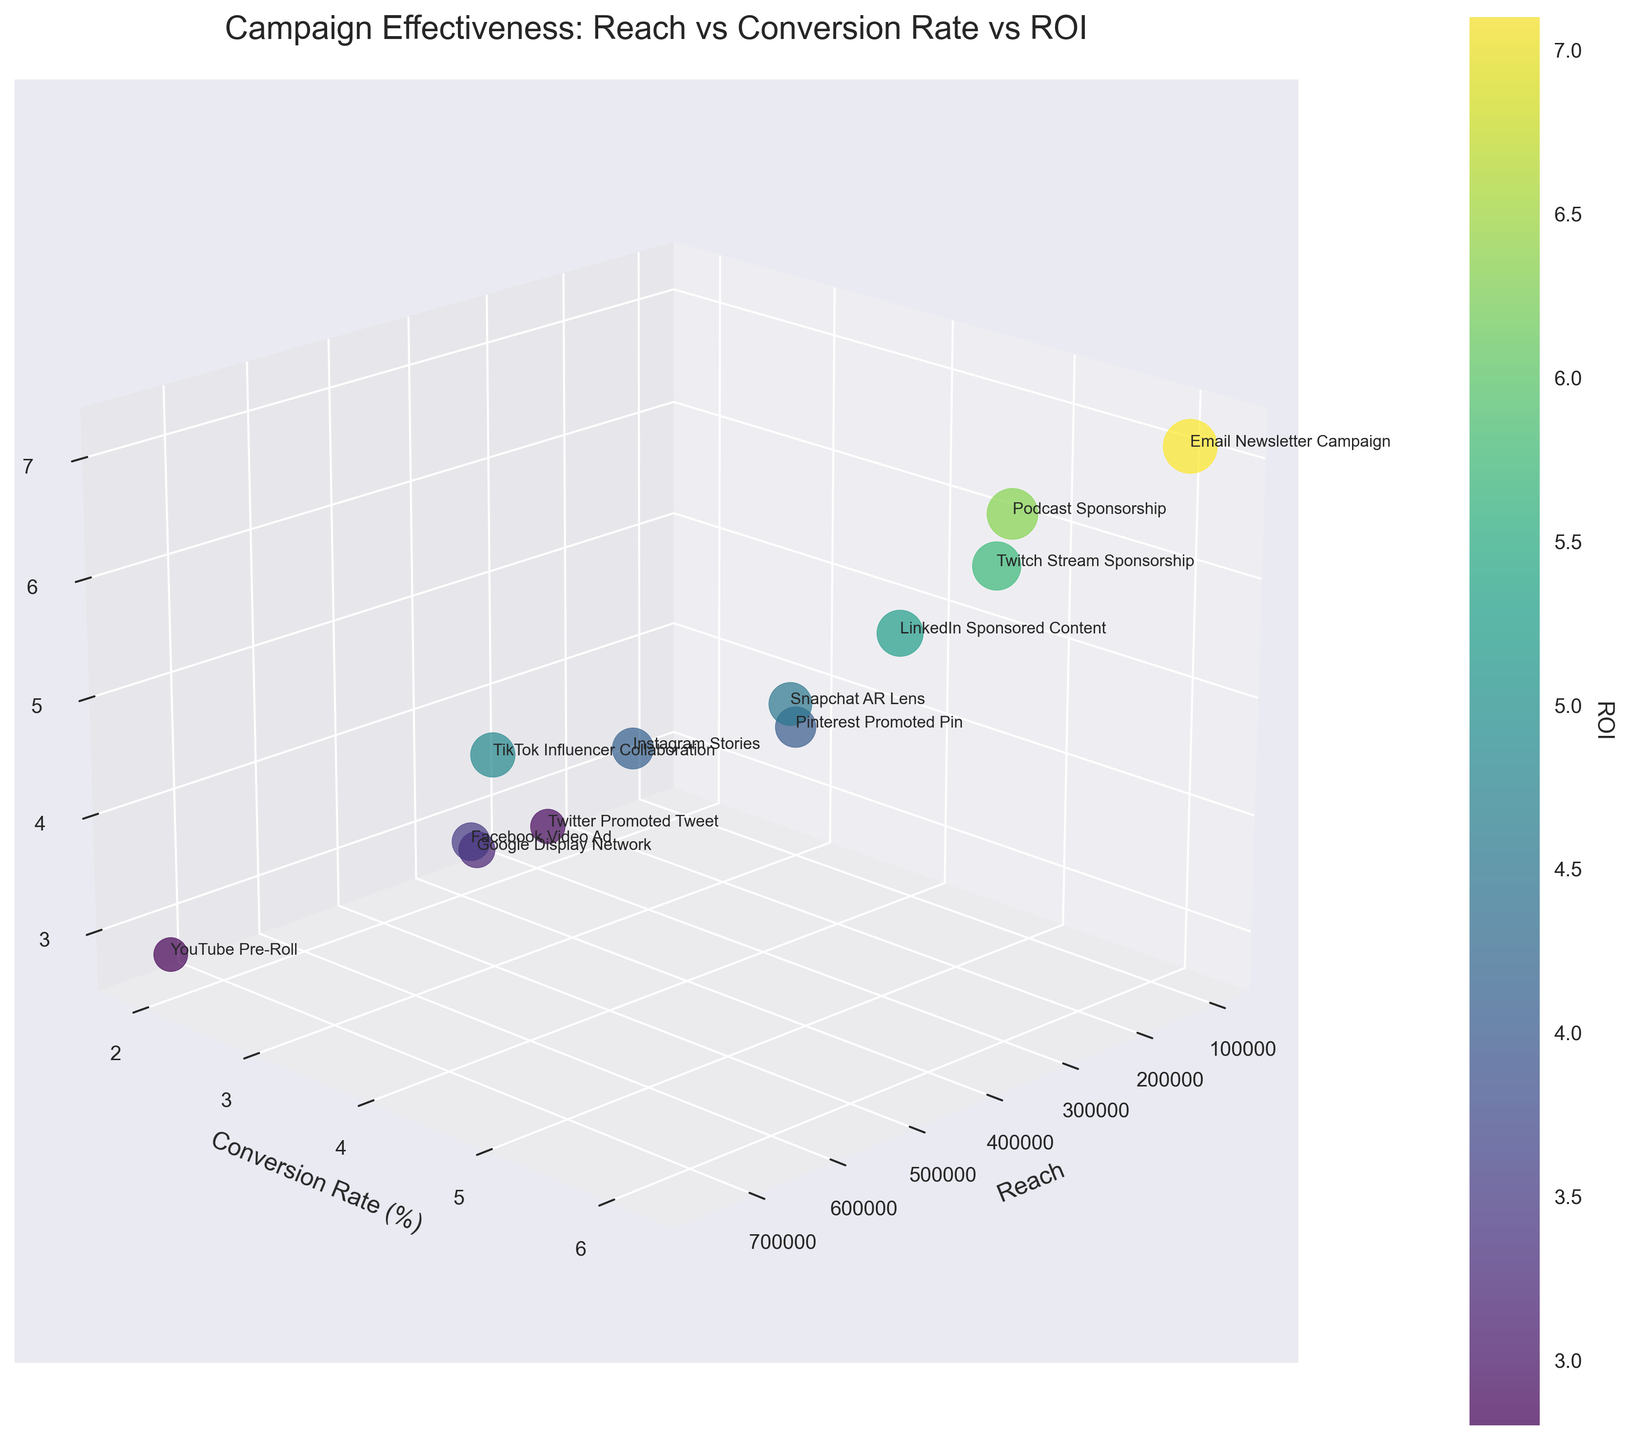How many campaigns are represented in the figure? Count the number of campaigns listed. There are 12 campaigns displayed, each represented by a different point in the 3D scatter plot.
Answer: 12 Which campaign has the highest Conversion Rate (%)? Identify the point in the scatter plot with the highest value on the 'Conversion Rate' axis. The Email Newsletter Campaign has the highest Conversion Rate of 6.2%.
Answer: Email Newsletter Campaign What is the approximate ROI for the TikTok Influencer Collaboration? Locate the point labeled 'TikTok Influencer Collaboration' and read the corresponding ROI value along the z-axis. The ROI is approximately 4.8.
Answer: 4.8 Which campaign has the lowest Reach, and what is its value? Find the point with the smallest value along the 'Reach' axis and identify its corresponding campaign. The Email Newsletter Campaign has the lowest Reach, which is 100,000.
Answer: Email Newsletter Campaign, 100,000 Between the Facebook Video Ad and the YouTube Pre-Roll, which has a higher ROI? Compare the z-values (ROI) of the points labeled 'Facebook Video Ad' and 'YouTube Pre-Roll'. Facebook Video Ad has a higher ROI of 3.5 compared to YouTube Pre-Roll's 2.8.
Answer: Facebook Video Ad Which campaign has the highest ROI and what is it? Identify the point with the highest value along the 'ROI' axis. The campaign with the highest ROI is Podcast Sponsorship, with an ROI of 6.3.
Answer: Podcast Sponsorship, 6.3 How does the Conversion Rate of Instagram Stories compare to that of Twitter Promoted Tweet? Compare the y-values (Conversion Rate) of the points labeled 'Instagram Stories' and 'Twitter Promoted Tweet'. Instagram Stories have a higher Conversion Rate of 3.2% compared to 2.1% for Twitter Promoted Tweet.
Answer: Instagram Stories What is the average ROI of the campaigns with a Reach greater than 500,000? Identify the campaigns with a Reach greater than 500,000, add their ROI values, and calculate the average. The campaigns are Facebook Video Ad (ROI 3.5), YouTube Pre-Roll (ROI 2.8), and TikTok Influencer Collaboration (ROI 4.8). The average ROI is (3.5 + 2.8 + 4.8) / 3 = 3.7.
Answer: 3.7 Which campaigns have an ROI of above 5 but below 6? Identify the points with ROI values between 5 and 6. The campaigns are LinkedIn Sponsored Content (ROI 5.2), Snapchat AR Lens (ROI 4.5), Podcast Sponsorship (ROI 6.3), and Email Newsletter Campaign (ROI 7.1). Filter to those between 5 and 6: LinkedIn Sponsored Content and Twitch Stream Sponsorship (ROI 5.7).
Answer: LinkedIn Sponsored Content, Twitch Stream Sponsorship 